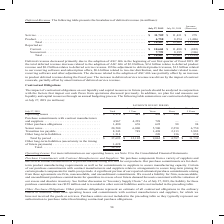According to Cisco Systems's financial document, How does the company believe that their liquidity and capital resources in future periods should be analyzed? in conjunction with the factors that impact our cash flows from operations discussed previously.. The document states: "tal resources in future periods should be analyzed in conjunction with the factors that impact our cash flows from operations discussed previously. In..." Also, What was the total operating leases in 2019? According to the financial document, 1,179 (in millions). The relevant text states: "to 5 Years More than 5 Years Operating leases . $ 1,179 $ 441 $ 494 $ 190 $ 54 Purchase commitments with contract manufacturers and suppliers . 4,967 4,239..." Also, What were the total other purchase obligations? According to the financial document, 1,490 (in millions). The relevant text states: "4,967 4,239 728 — — Other purchase obligations . 1,490 676 622 98 94 Senior notes . 20,500 6,000 5,500 2,250 6,750 Transition tax payable . 8,343 749 1,49..." Also, can you calculate: What was the difference in operating leases between those that were less than 1 year and 1 to 3 years? Based on the calculation: 494-441, the result is 53 (in millions). This is based on the information: "rs More than 5 Years Operating leases . $ 1,179 $ 441 $ 494 $ 190 $ 54 Purchase commitments with contract manufacturers and suppliers . 4,967 4,239 728 — e than 5 Years Operating leases . $ 1,179 $ 44..." The key data points involved are: 441, 494. Also, can you calculate: What was the total senior notes as a percentage of total contractual obligations? Based on the calculation: 20,500/39,121, the result is 52.4 (percentage). This is based on the information: "obligations . 1,490 676 622 98 94 Senior notes . 20,500 6,000 5,500 2,250 6,750 Transition tax payable . 8,343 749 1,498 2,113 3,983 Other long-term liabil the timing of future payments) . 1,428 Total..." The key data points involved are: 20,500, 39,121. Additionally, What is the period that has the greatest Operating leases? According to the financial document, 1 to 3 Years. The relevant text states: "July 27, 2019 Total Less than 1 Year 1 to 3 Years 3 to 5 Years More than 5 Years Operating leases . $ 1,179 $ 441 $ 494 $ 190 $ 54 Purchase commitmen..." 